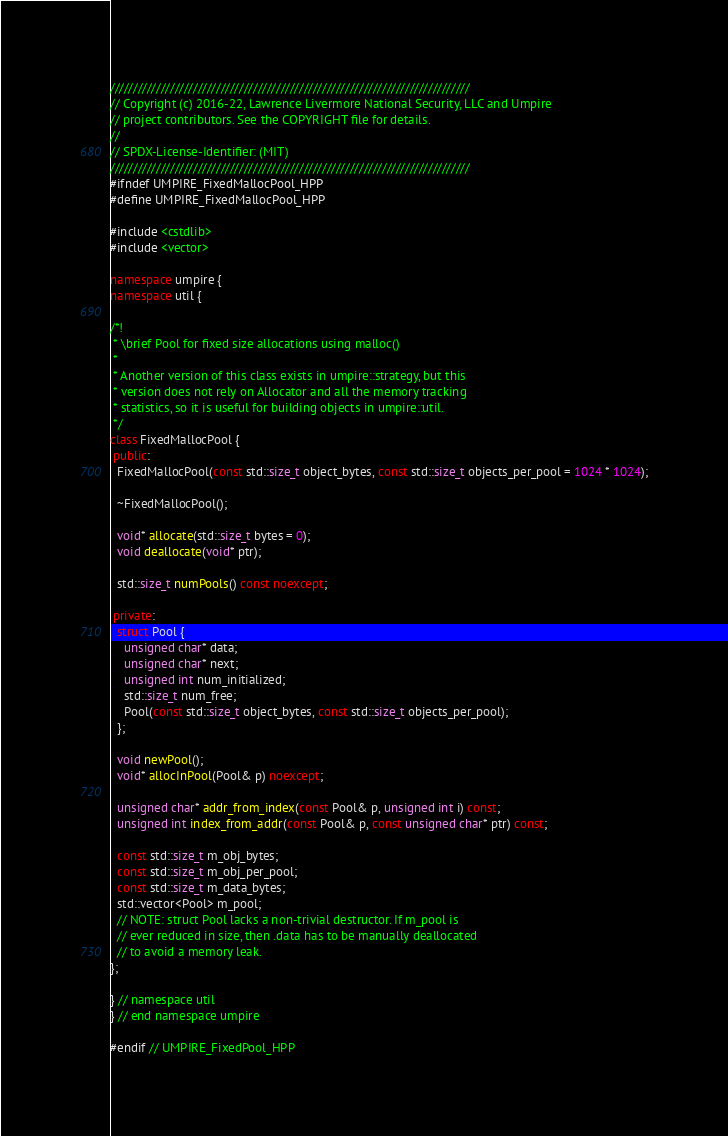Convert code to text. <code><loc_0><loc_0><loc_500><loc_500><_C++_>//////////////////////////////////////////////////////////////////////////////
// Copyright (c) 2016-22, Lawrence Livermore National Security, LLC and Umpire
// project contributors. See the COPYRIGHT file for details.
//
// SPDX-License-Identifier: (MIT)
//////////////////////////////////////////////////////////////////////////////
#ifndef UMPIRE_FixedMallocPool_HPP
#define UMPIRE_FixedMallocPool_HPP

#include <cstdlib>
#include <vector>

namespace umpire {
namespace util {

/*!
 * \brief Pool for fixed size allocations using malloc()
 *
 * Another version of this class exists in umpire::strategy, but this
 * version does not rely on Allocator and all the memory tracking
 * statistics, so it is useful for building objects in umpire::util.
 */
class FixedMallocPool {
 public:
  FixedMallocPool(const std::size_t object_bytes, const std::size_t objects_per_pool = 1024 * 1024);

  ~FixedMallocPool();

  void* allocate(std::size_t bytes = 0);
  void deallocate(void* ptr);

  std::size_t numPools() const noexcept;

 private:
  struct Pool {
    unsigned char* data;
    unsigned char* next;
    unsigned int num_initialized;
    std::size_t num_free;
    Pool(const std::size_t object_bytes, const std::size_t objects_per_pool);
  };

  void newPool();
  void* allocInPool(Pool& p) noexcept;

  unsigned char* addr_from_index(const Pool& p, unsigned int i) const;
  unsigned int index_from_addr(const Pool& p, const unsigned char* ptr) const;

  const std::size_t m_obj_bytes;
  const std::size_t m_obj_per_pool;
  const std::size_t m_data_bytes;
  std::vector<Pool> m_pool;
  // NOTE: struct Pool lacks a non-trivial destructor. If m_pool is
  // ever reduced in size, then .data has to be manually deallocated
  // to avoid a memory leak.
};

} // namespace util
} // end namespace umpire

#endif // UMPIRE_FixedPool_HPP
</code> 